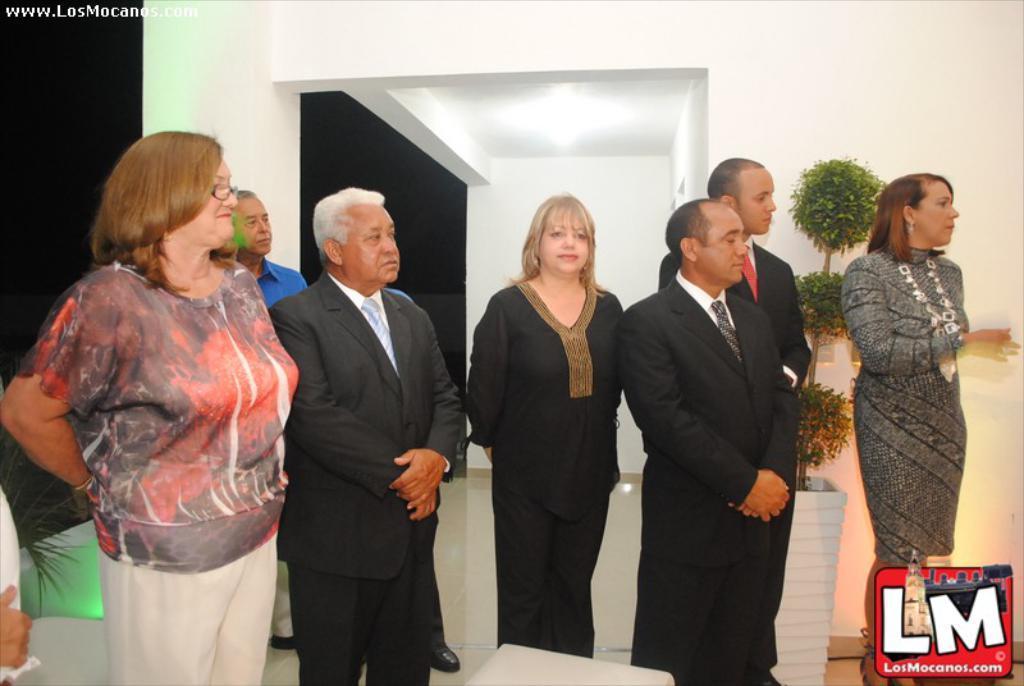Could you give a brief overview of what you see in this image? This is an inside view of a room. Here I can see few people are standing and looking towards the right side. At the back of these people I can see two house plants. In the background, I can see the wall. 